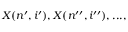Convert formula to latex. <formula><loc_0><loc_0><loc_500><loc_500>X ( n ^ { \prime } , i ^ { \prime } ) , X ( n ^ { \prime \prime } , i ^ { \prime \prime } ) , \dots ,</formula> 